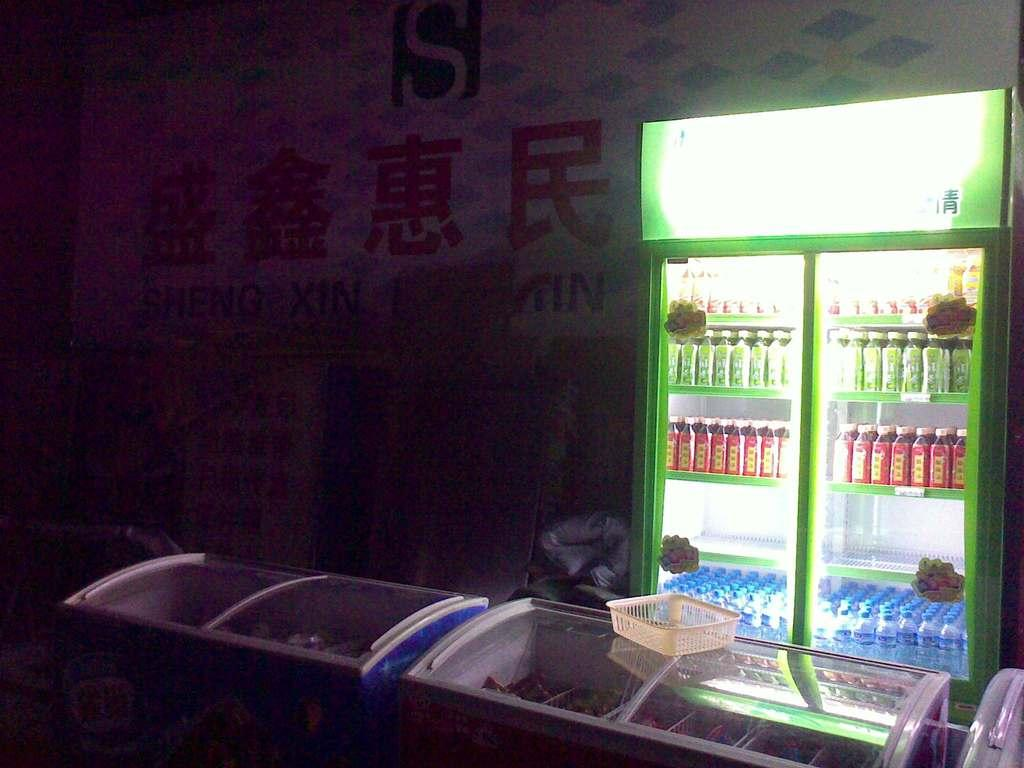<image>
Describe the image concisely. a sign above some drinks that has Japanese symbols on it 